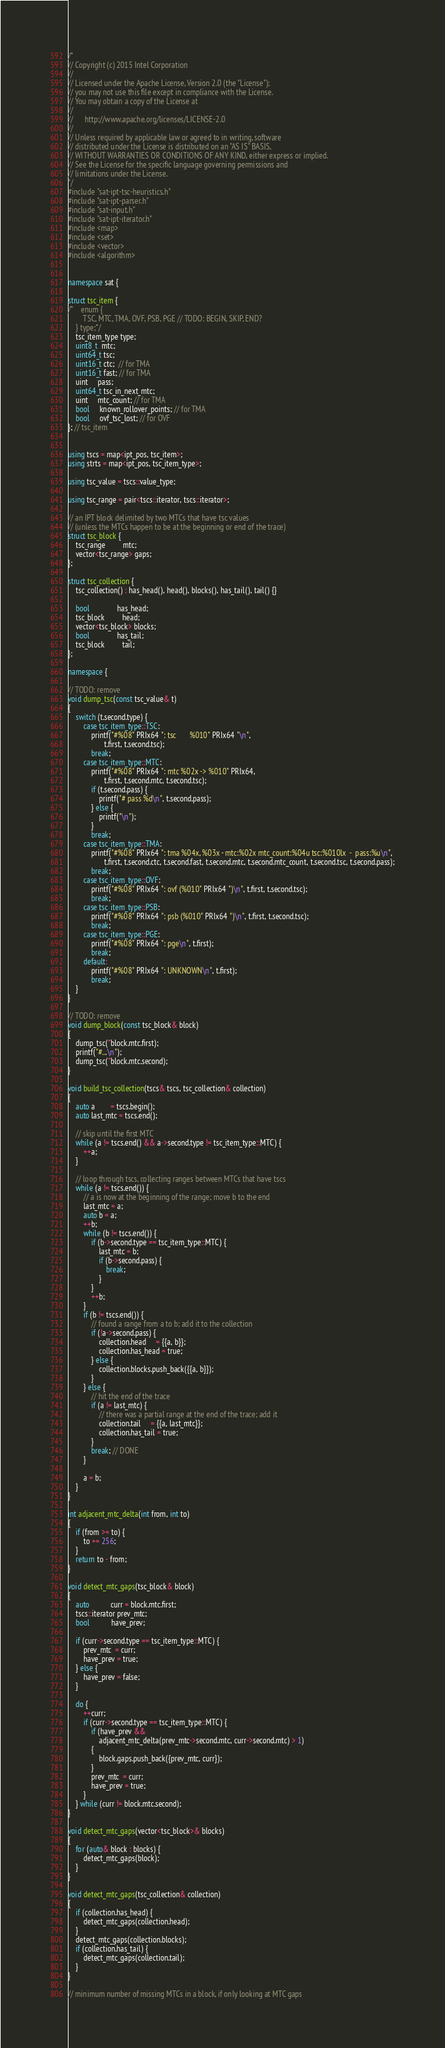Convert code to text. <code><loc_0><loc_0><loc_500><loc_500><_C++_>/*
// Copyright (c) 2015 Intel Corporation
//
// Licensed under the Apache License, Version 2.0 (the "License");
// you may not use this file except in compliance with the License.
// You may obtain a copy of the License at
//
//      http://www.apache.org/licenses/LICENSE-2.0
//
// Unless required by applicable law or agreed to in writing, software
// distributed under the License is distributed on an "AS IS" BASIS,
// WITHOUT WARRANTIES OR CONDITIONS OF ANY KIND, either express or implied.
// See the License for the specific language governing permissions and
// limitations under the License.
*/
#include "sat-ipt-tsc-heuristics.h"
#include "sat-ipt-parser.h"
#include "sat-input.h"
#include "sat-ipt-iterator.h"
#include <map>
#include <set>
#include <vector>
#include <algorithm>


namespace sat {

struct tsc_item {
/*    enum {
        TSC, MTC, TMA, OVF, PSB, PGE // TODO: BEGIN, SKIP, END?
    } type;*/
    tsc_item_type type;
    uint8_t  mtc;
    uint64_t tsc;
    uint16_t ctc;  // for TMA
    uint16_t fast; // for TMA
    uint     pass;
    uint64_t tsc_in_next_mtc;
    uint     mtc_count; // for TMA
    bool     known_rollover_points; // for TMA
    bool     ovf_tsc_lost; // for OVF
}; // tsc_item


using tscs = map<ipt_pos, tsc_item>;
using strts = map<ipt_pos, tsc_item_type>;

using tsc_value = tscs::value_type;

using tsc_range = pair<tscs::iterator, tscs::iterator>;

// an IPT block delimited by two MTCs that have tsc values
// (unless the MTCs happen to be at the beginning or end of the trace)
struct tsc_block {
    tsc_range         mtc;
    vector<tsc_range> gaps;
};

struct tsc_collection {
    tsc_collection() : has_head(), head(), blocks(), has_tail(), tail() {}

    bool              has_head;
    tsc_block         head;
    vector<tsc_block> blocks;
    bool              has_tail;
    tsc_block         tail;
};

namespace {

// TODO: remove
void dump_tsc(const tsc_value& t)
{
    switch (t.second.type) {
        case tsc_item_type::TSC:
            printf("#%08" PRIx64 ": tsc       %010" PRIx64 "\n",
                   t.first, t.second.tsc);
            break;
        case tsc_item_type::MTC:
            printf("#%08" PRIx64 ": mtc %02x -> %010" PRIx64,
                   t.first, t.second.mtc, t.second.tsc);
            if (t.second.pass) {
                printf("# pass %d\n", t.second.pass);
            } else {
                printf("\n");
            }
            break;
        case tsc_item_type::TMA:
            printf("#%08" PRIx64 ": tma %04x, %03x - mtc:%02x mtc_count:%04u tsc:%010lx  -  pass:%u\n",
                   t.first, t.second.ctc, t.second.fast, t.second.mtc, t.second.mtc_count, t.second.tsc, t.second.pass);
            break;
        case tsc_item_type::OVF:
            printf("#%08" PRIx64 ": ovf (%010" PRIx64 ")\n", t.first, t.second.tsc);
            break;
        case tsc_item_type::PSB:
            printf("#%08" PRIx64 ": psb (%010" PRIx64 ")\n", t.first, t.second.tsc);
            break;
        case tsc_item_type::PGE:
            printf("#%08" PRIx64 ": pge\n", t.first);
            break;
        default:
            printf("#%08" PRIx64 ": UNKNOWN\n", t.first);
            break;
    }
}

// TODO: remove
void dump_block(const tsc_block& block)
{
    dump_tsc(*block.mtc.first);
    printf("#...\n");
    dump_tsc(*block.mtc.second);
}

void build_tsc_collection(tscs& tscs, tsc_collection& collection)
{
    auto a        = tscs.begin();
    auto last_mtc = tscs.end();

    // skip until the first MTC
    while (a != tscs.end() && a->second.type != tsc_item_type::MTC) {
        ++a;
    }

    // loop through tscs, collecting ranges between MTCs that have tscs
    while (a != tscs.end()) {
        // a is now at the beginning of the range; move b to the end
        last_mtc = a;
        auto b = a;
        ++b;
        while (b != tscs.end()) {
            if (b->second.type == tsc_item_type::MTC) {
                last_mtc = b;
                if (b->second.pass) {
                    break;
                }
            }
            ++b;
        }
        if (b != tscs.end()) {
            // found a range from a to b; add it to the collection
            if (!a->second.pass) {
                collection.head     = {{a, b}};
                collection.has_head = true;
            } else {
                collection.blocks.push_back({{a, b}});
            }
        } else {
            // hit the end of the trace
            if (a != last_mtc) {
                // there was a partial range at the end of the trace; add it
                collection.tail     = {{a, last_mtc}};
                collection.has_tail = true;
            }
            break; // DONE
        }

        a = b;
    }
}

int adjacent_mtc_delta(int from, int to)
{
    if (from >= to) {
        to += 256;
    }
    return to - from;
}

void detect_mtc_gaps(tsc_block& block)
{
    auto           curr = block.mtc.first;
    tscs::iterator prev_mtc;
    bool           have_prev;

    if (curr->second.type == tsc_item_type::MTC) {
        prev_mtc  = curr;
        have_prev = true;
    } else {
        have_prev = false;
    }

    do {
        ++curr;
        if (curr->second.type == tsc_item_type::MTC) {
            if (have_prev &&
                adjacent_mtc_delta(prev_mtc->second.mtc, curr->second.mtc) > 1)
            {
                block.gaps.push_back({prev_mtc, curr});
            }
            prev_mtc  = curr;
            have_prev = true;
        }
    } while (curr != block.mtc.second);
}

void detect_mtc_gaps(vector<tsc_block>& blocks)
{
    for (auto& block : blocks) {
        detect_mtc_gaps(block);
    }
}

void detect_mtc_gaps(tsc_collection& collection)
{
    if (collection.has_head) {
        detect_mtc_gaps(collection.head);
    }
    detect_mtc_gaps(collection.blocks);
    if (collection.has_tail) {
        detect_mtc_gaps(collection.tail);
    }
}

// minimum number of missing MTCs in a block, if only looking at MTC gaps</code> 